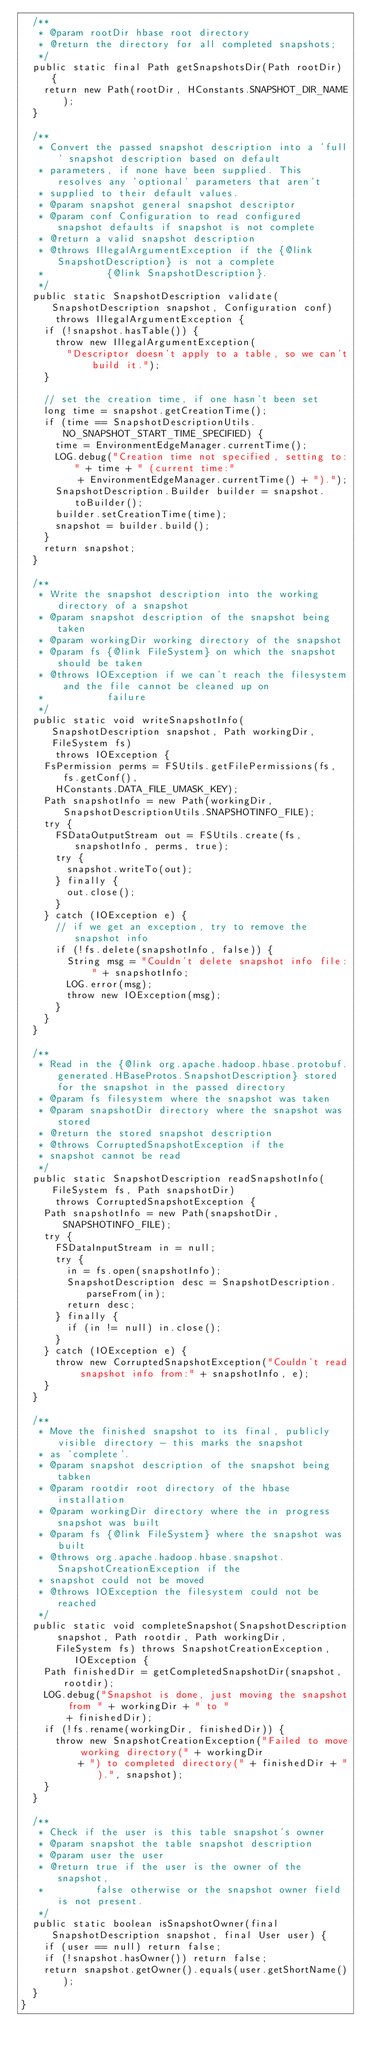Convert code to text. <code><loc_0><loc_0><loc_500><loc_500><_Java_>  /**
   * @param rootDir hbase root directory
   * @return the directory for all completed snapshots;
   */
  public static final Path getSnapshotsDir(Path rootDir) {
    return new Path(rootDir, HConstants.SNAPSHOT_DIR_NAME);
  }

  /**
   * Convert the passed snapshot description into a 'full' snapshot description based on default
   * parameters, if none have been supplied. This resolves any 'optional' parameters that aren't
   * supplied to their default values.
   * @param snapshot general snapshot descriptor
   * @param conf Configuration to read configured snapshot defaults if snapshot is not complete
   * @return a valid snapshot description
   * @throws IllegalArgumentException if the {@link SnapshotDescription} is not a complete
   *           {@link SnapshotDescription}.
   */
  public static SnapshotDescription validate(SnapshotDescription snapshot, Configuration conf)
      throws IllegalArgumentException {
    if (!snapshot.hasTable()) {
      throw new IllegalArgumentException(
        "Descriptor doesn't apply to a table, so we can't build it.");
    }

    // set the creation time, if one hasn't been set
    long time = snapshot.getCreationTime();
    if (time == SnapshotDescriptionUtils.NO_SNAPSHOT_START_TIME_SPECIFIED) {
      time = EnvironmentEdgeManager.currentTime();
      LOG.debug("Creation time not specified, setting to:" + time + " (current time:"
          + EnvironmentEdgeManager.currentTime() + ").");
      SnapshotDescription.Builder builder = snapshot.toBuilder();
      builder.setCreationTime(time);
      snapshot = builder.build();
    }
    return snapshot;
  }

  /**
   * Write the snapshot description into the working directory of a snapshot
   * @param snapshot description of the snapshot being taken
   * @param workingDir working directory of the snapshot
   * @param fs {@link FileSystem} on which the snapshot should be taken
   * @throws IOException if we can't reach the filesystem and the file cannot be cleaned up on
   *           failure
   */
  public static void writeSnapshotInfo(SnapshotDescription snapshot, Path workingDir, FileSystem fs)
      throws IOException {
    FsPermission perms = FSUtils.getFilePermissions(fs, fs.getConf(),
      HConstants.DATA_FILE_UMASK_KEY);
    Path snapshotInfo = new Path(workingDir, SnapshotDescriptionUtils.SNAPSHOTINFO_FILE);
    try {
      FSDataOutputStream out = FSUtils.create(fs, snapshotInfo, perms, true);
      try {
        snapshot.writeTo(out);
      } finally {
        out.close();
      }
    } catch (IOException e) {
      // if we get an exception, try to remove the snapshot info
      if (!fs.delete(snapshotInfo, false)) {
        String msg = "Couldn't delete snapshot info file: " + snapshotInfo;
        LOG.error(msg);
        throw new IOException(msg);
      }
    }
  }

  /**
   * Read in the {@link org.apache.hadoop.hbase.protobuf.generated.HBaseProtos.SnapshotDescription} stored for the snapshot in the passed directory
   * @param fs filesystem where the snapshot was taken
   * @param snapshotDir directory where the snapshot was stored
   * @return the stored snapshot description
   * @throws CorruptedSnapshotException if the
   * snapshot cannot be read
   */
  public static SnapshotDescription readSnapshotInfo(FileSystem fs, Path snapshotDir)
      throws CorruptedSnapshotException {
    Path snapshotInfo = new Path(snapshotDir, SNAPSHOTINFO_FILE);
    try {
      FSDataInputStream in = null;
      try {
        in = fs.open(snapshotInfo);
        SnapshotDescription desc = SnapshotDescription.parseFrom(in);
        return desc;
      } finally {
        if (in != null) in.close();
      }
    } catch (IOException e) {
      throw new CorruptedSnapshotException("Couldn't read snapshot info from:" + snapshotInfo, e);
    }
  }

  /**
   * Move the finished snapshot to its final, publicly visible directory - this marks the snapshot
   * as 'complete'.
   * @param snapshot description of the snapshot being tabken
   * @param rootdir root directory of the hbase installation
   * @param workingDir directory where the in progress snapshot was built
   * @param fs {@link FileSystem} where the snapshot was built
   * @throws org.apache.hadoop.hbase.snapshot.SnapshotCreationException if the
   * snapshot could not be moved
   * @throws IOException the filesystem could not be reached
   */
  public static void completeSnapshot(SnapshotDescription snapshot, Path rootdir, Path workingDir,
      FileSystem fs) throws SnapshotCreationException, IOException {
    Path finishedDir = getCompletedSnapshotDir(snapshot, rootdir);
    LOG.debug("Snapshot is done, just moving the snapshot from " + workingDir + " to "
        + finishedDir);
    if (!fs.rename(workingDir, finishedDir)) {
      throw new SnapshotCreationException("Failed to move working directory(" + workingDir
          + ") to completed directory(" + finishedDir + ").", snapshot);
    }
  }

  /**
   * Check if the user is this table snapshot's owner
   * @param snapshot the table snapshot description
   * @param user the user
   * @return true if the user is the owner of the snapshot,
   *         false otherwise or the snapshot owner field is not present.
   */
  public static boolean isSnapshotOwner(final SnapshotDescription snapshot, final User user) {
    if (user == null) return false;
    if (!snapshot.hasOwner()) return false;
    return snapshot.getOwner().equals(user.getShortName());
  }
}
</code> 